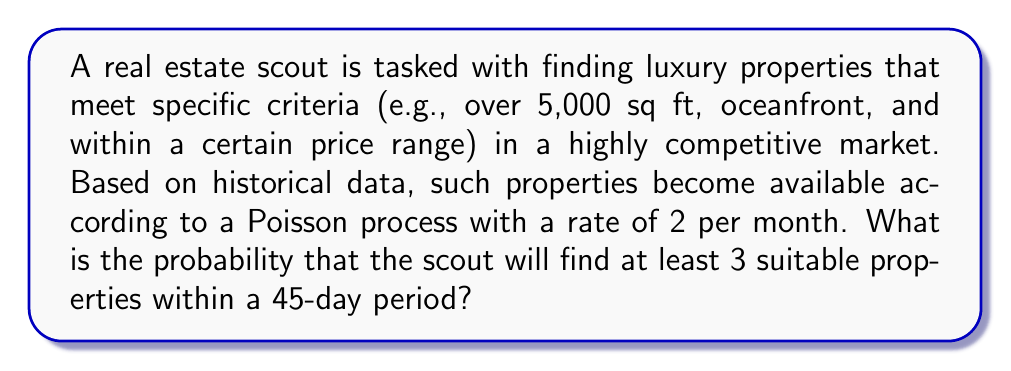Show me your answer to this math problem. Let's approach this step-by-step:

1) We are dealing with a Poisson process where:
   - The rate $\lambda$ is 2 properties per month
   - The time period $t$ is 45 days, which is 1.5 months

2) First, we need to calculate the average number of properties ($\mu$) expected in 1.5 months:
   $$\mu = \lambda t = 2 \times 1.5 = 3$$

3) We want to find the probability of at least 3 properties, which is equivalent to the probability of not finding 0, 1, or 2 properties:
   $$P(X \geq 3) = 1 - P(X < 3) = 1 - [P(X=0) + P(X=1) + P(X=2)]$$

4) The probability of exactly $k$ events in a Poisson process is given by:
   $$P(X=k) = \frac{e^{-\mu} \mu^k}{k!}$$

5) Let's calculate each probability:
   $$P(X=0) = \frac{e^{-3} 3^0}{0!} = e^{-3} \approx 0.0498$$
   $$P(X=1) = \frac{e^{-3} 3^1}{1!} = 3e^{-3} \approx 0.1494$$
   $$P(X=2) = \frac{e^{-3} 3^2}{2!} = \frac{9e^{-3}}{2} \approx 0.2240$$

6) Now we can calculate the probability of at least 3 properties:
   $$P(X \geq 3) = 1 - [P(X=0) + P(X=1) + P(X=2)]$$
   $$= 1 - (0.0498 + 0.1494 + 0.2240)$$
   $$= 1 - 0.4232 = 0.5768$$

Thus, the probability of finding at least 3 suitable properties within 45 days is approximately 0.5768 or 57.68%.
Answer: 0.5768 